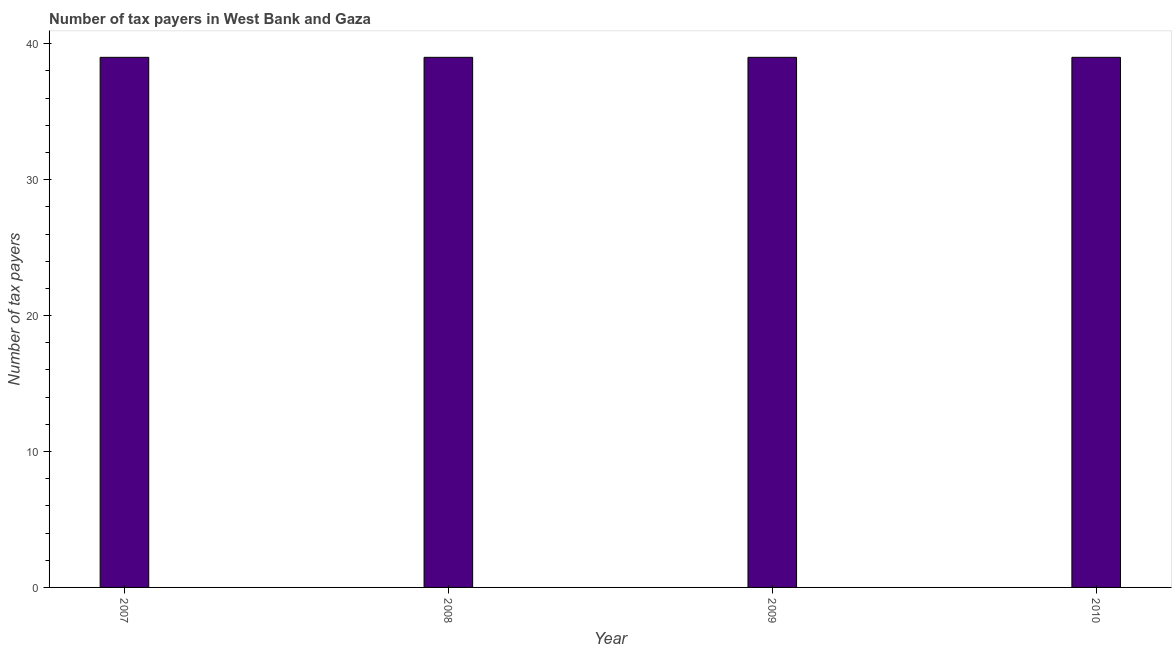What is the title of the graph?
Provide a short and direct response. Number of tax payers in West Bank and Gaza. What is the label or title of the Y-axis?
Your response must be concise. Number of tax payers. What is the number of tax payers in 2010?
Make the answer very short. 39. In which year was the number of tax payers maximum?
Your answer should be very brief. 2007. What is the sum of the number of tax payers?
Make the answer very short. 156. What is the median number of tax payers?
Keep it short and to the point. 39. Do a majority of the years between 2008 and 2009 (inclusive) have number of tax payers greater than 4 ?
Offer a very short reply. Yes. What is the ratio of the number of tax payers in 2007 to that in 2009?
Keep it short and to the point. 1. Is the number of tax payers in 2008 less than that in 2009?
Your answer should be very brief. No. Is the difference between the number of tax payers in 2008 and 2009 greater than the difference between any two years?
Keep it short and to the point. Yes. What is the difference between the highest and the second highest number of tax payers?
Make the answer very short. 0. In how many years, is the number of tax payers greater than the average number of tax payers taken over all years?
Provide a short and direct response. 0. Are all the bars in the graph horizontal?
Offer a very short reply. No. What is the difference between two consecutive major ticks on the Y-axis?
Offer a very short reply. 10. What is the Number of tax payers in 2007?
Provide a short and direct response. 39. What is the difference between the Number of tax payers in 2007 and 2008?
Ensure brevity in your answer.  0. What is the difference between the Number of tax payers in 2007 and 2010?
Your response must be concise. 0. What is the difference between the Number of tax payers in 2008 and 2010?
Keep it short and to the point. 0. What is the difference between the Number of tax payers in 2009 and 2010?
Your response must be concise. 0. What is the ratio of the Number of tax payers in 2007 to that in 2008?
Ensure brevity in your answer.  1. 